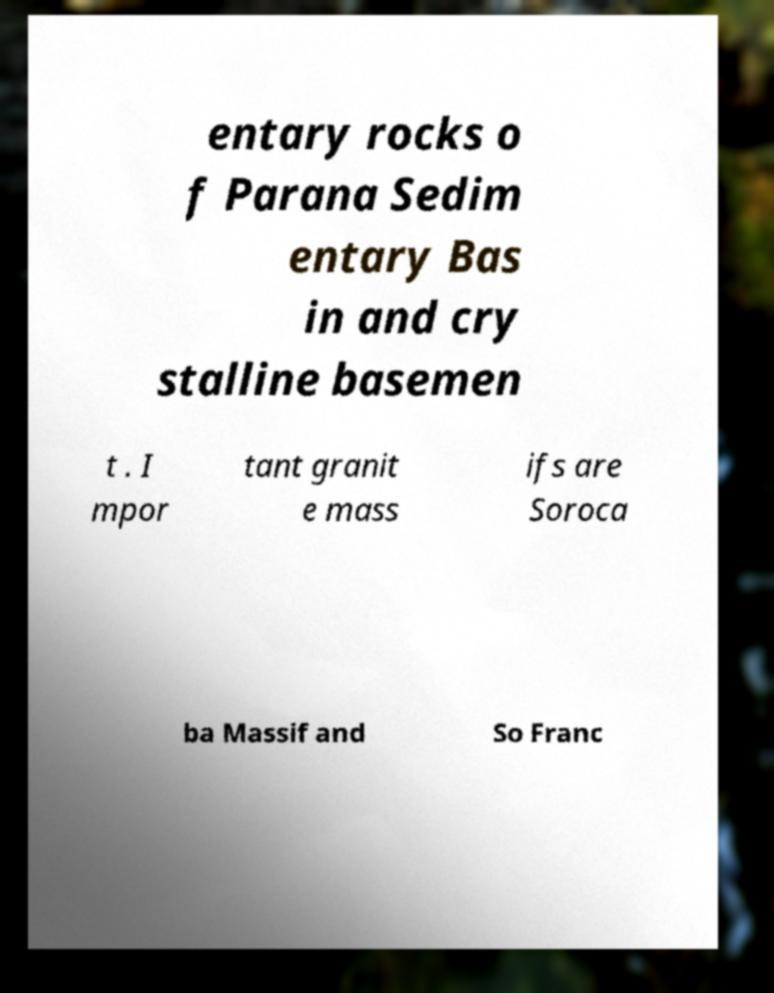For documentation purposes, I need the text within this image transcribed. Could you provide that? entary rocks o f Parana Sedim entary Bas in and cry stalline basemen t . I mpor tant granit e mass ifs are Soroca ba Massif and So Franc 